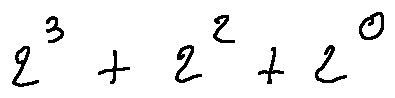<formula> <loc_0><loc_0><loc_500><loc_500>2 ^ { 3 } + 2 ^ { 2 } + 2 ^ { 0 }</formula> 